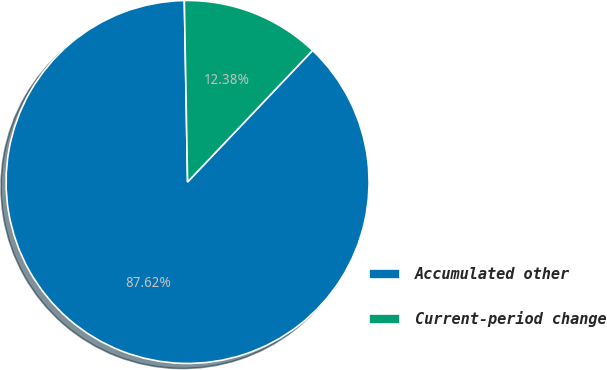Convert chart to OTSL. <chart><loc_0><loc_0><loc_500><loc_500><pie_chart><fcel>Accumulated other<fcel>Current-period change<nl><fcel>87.62%<fcel>12.38%<nl></chart> 